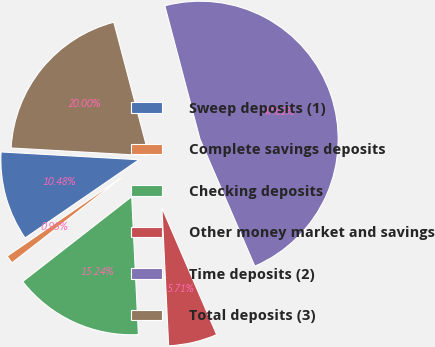<chart> <loc_0><loc_0><loc_500><loc_500><pie_chart><fcel>Sweep deposits (1)<fcel>Complete savings deposits<fcel>Checking deposits<fcel>Other money market and savings<fcel>Time deposits (2)<fcel>Total deposits (3)<nl><fcel>10.48%<fcel>0.95%<fcel>15.24%<fcel>5.71%<fcel>47.62%<fcel>20.0%<nl></chart> 